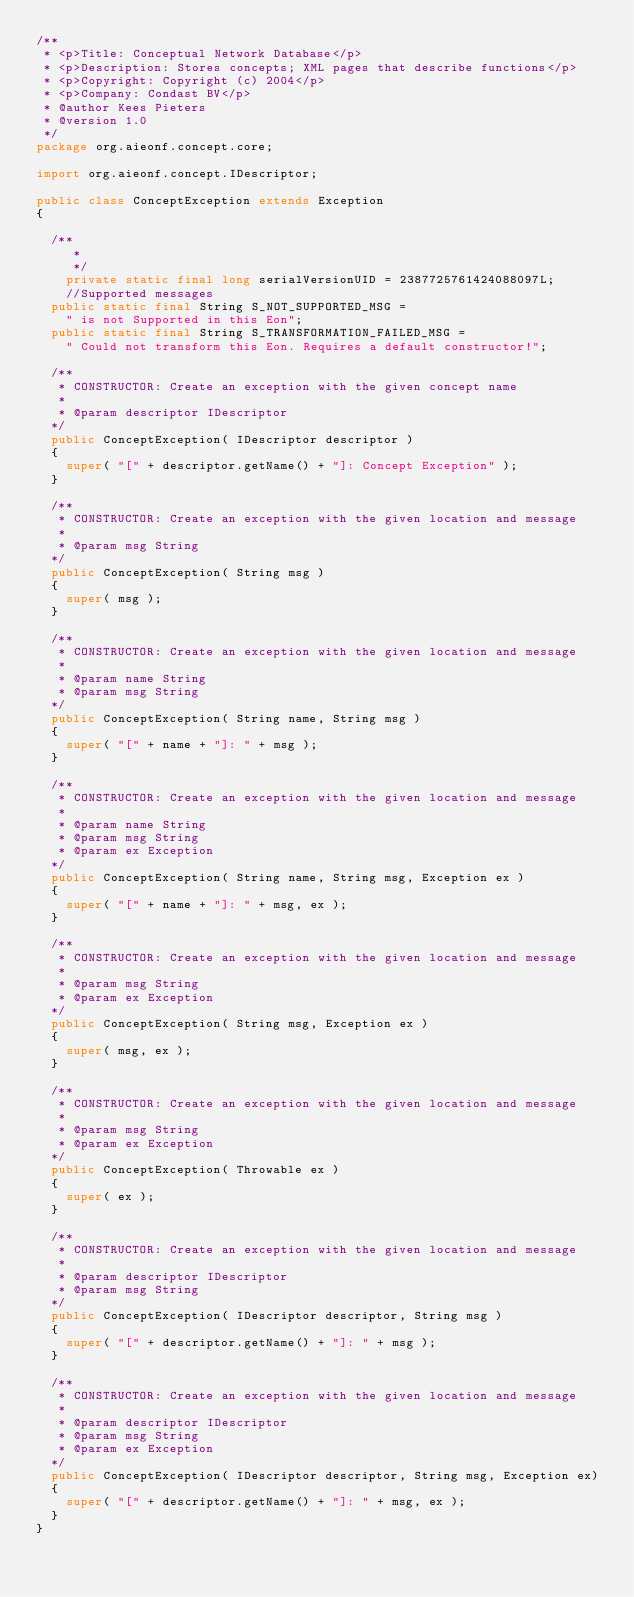<code> <loc_0><loc_0><loc_500><loc_500><_Java_>/**
 * <p>Title: Conceptual Network Database</p>
 * <p>Description: Stores concepts; XML pages that describe functions</p>
 * <p>Copyright: Copyright (c) 2004</p>
 * <p>Company: Condast BV</p>
 * @author Kees Pieters
 * @version 1.0
 */
package org.aieonf.concept.core;

import org.aieonf.concept.IDescriptor;

public class ConceptException extends Exception
{

  /**
	 * 
	 */
	private static final long serialVersionUID = 2387725761424088097L;
	//Supported messages
  public static final String S_NOT_SUPPORTED_MSG =
    " is not Supported in this Eon";
  public static final String S_TRANSFORMATION_FAILED_MSG =
    " Could not transform this Eon. Requires a default constructor!";

  /**
   * CONSTRUCTOR: Create an exception with the given concept name
   *
   * @param descriptor IDescriptor
  */
  public ConceptException( IDescriptor descriptor )
  {
    super( "[" + descriptor.getName() + "]: Concept Exception" );
  }

  /**
   * CONSTRUCTOR: Create an exception with the given location and message
   *
   * @param msg String
  */
  public ConceptException( String msg )
  {
    super( msg );
  }

  /**
   * CONSTRUCTOR: Create an exception with the given location and message
   *
   * @param name String
   * @param msg String
  */
  public ConceptException( String name, String msg )
  {
    super( "[" + name + "]: " + msg );
  }

  /**
   * CONSTRUCTOR: Create an exception with the given location and message
   *
   * @param name String
   * @param msg String
   * @param ex Exception
  */
  public ConceptException( String name, String msg, Exception ex )
  {
    super( "[" + name + "]: " + msg, ex );
  }

  /**
   * CONSTRUCTOR: Create an exception with the given location and message
   *
   * @param msg String
   * @param ex Exception
  */
  public ConceptException( String msg, Exception ex )
  {
    super( msg, ex );
  }

  /**
   * CONSTRUCTOR: Create an exception with the given location and message
   *
   * @param msg String
   * @param ex Exception
  */
  public ConceptException( Throwable ex )
  {
    super( ex );
  }

  /**
   * CONSTRUCTOR: Create an exception with the given location and message
   *
   * @param descriptor IDescriptor
   * @param msg String
  */
  public ConceptException( IDescriptor descriptor, String msg )
  {
    super( "[" + descriptor.getName() + "]: " + msg );
  }

  /**
   * CONSTRUCTOR: Create an exception with the given location and message
   *
   * @param descriptor IDescriptor
   * @param msg String
   * @param ex Exception
  */
  public ConceptException( IDescriptor descriptor, String msg, Exception ex)
  {
    super( "[" + descriptor.getName() + "]: " + msg, ex );
  }
}
</code> 